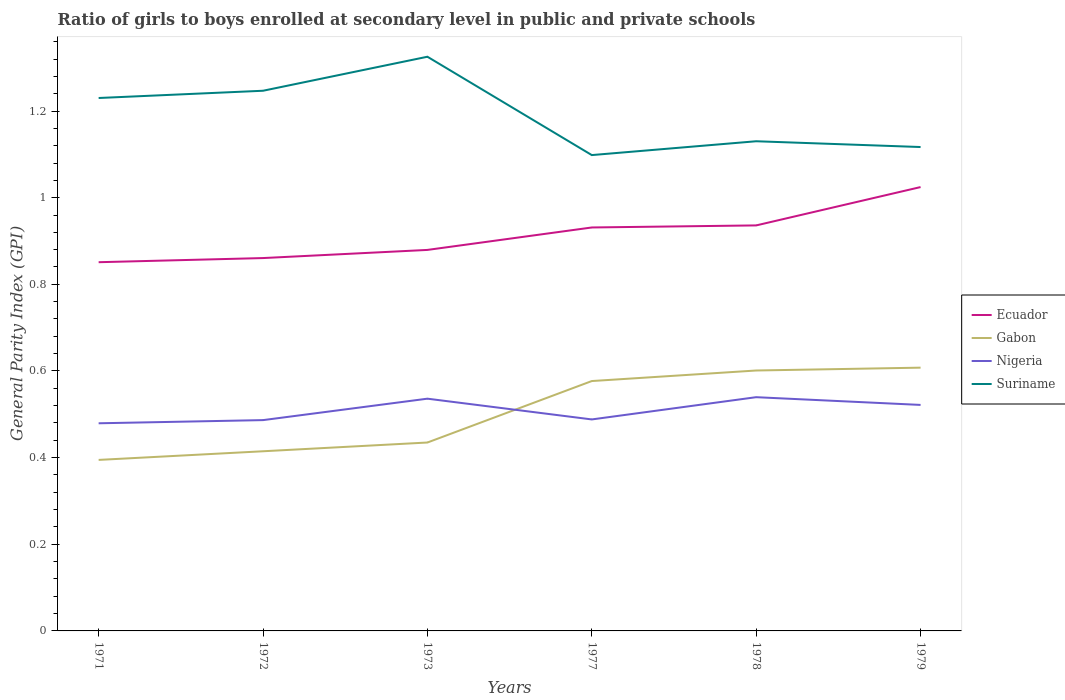How many different coloured lines are there?
Keep it short and to the point. 4. Across all years, what is the maximum general parity index in Nigeria?
Provide a succinct answer. 0.48. In which year was the general parity index in Suriname maximum?
Ensure brevity in your answer.  1977. What is the total general parity index in Nigeria in the graph?
Make the answer very short. 0.02. What is the difference between the highest and the second highest general parity index in Suriname?
Provide a short and direct response. 0.23. Is the general parity index in Ecuador strictly greater than the general parity index in Gabon over the years?
Your answer should be compact. No. How many years are there in the graph?
Give a very brief answer. 6. Does the graph contain any zero values?
Your answer should be very brief. No. Where does the legend appear in the graph?
Provide a succinct answer. Center right. How are the legend labels stacked?
Offer a very short reply. Vertical. What is the title of the graph?
Provide a short and direct response. Ratio of girls to boys enrolled at secondary level in public and private schools. What is the label or title of the X-axis?
Your answer should be compact. Years. What is the label or title of the Y-axis?
Ensure brevity in your answer.  General Parity Index (GPI). What is the General Parity Index (GPI) in Ecuador in 1971?
Keep it short and to the point. 0.85. What is the General Parity Index (GPI) of Gabon in 1971?
Offer a terse response. 0.39. What is the General Parity Index (GPI) in Nigeria in 1971?
Provide a succinct answer. 0.48. What is the General Parity Index (GPI) in Suriname in 1971?
Offer a terse response. 1.23. What is the General Parity Index (GPI) of Ecuador in 1972?
Offer a very short reply. 0.86. What is the General Parity Index (GPI) of Gabon in 1972?
Your answer should be compact. 0.41. What is the General Parity Index (GPI) of Nigeria in 1972?
Make the answer very short. 0.49. What is the General Parity Index (GPI) of Suriname in 1972?
Ensure brevity in your answer.  1.25. What is the General Parity Index (GPI) in Ecuador in 1973?
Your answer should be very brief. 0.88. What is the General Parity Index (GPI) of Gabon in 1973?
Your answer should be very brief. 0.43. What is the General Parity Index (GPI) in Nigeria in 1973?
Provide a succinct answer. 0.54. What is the General Parity Index (GPI) in Suriname in 1973?
Provide a succinct answer. 1.33. What is the General Parity Index (GPI) in Ecuador in 1977?
Offer a very short reply. 0.93. What is the General Parity Index (GPI) of Gabon in 1977?
Offer a terse response. 0.58. What is the General Parity Index (GPI) of Nigeria in 1977?
Keep it short and to the point. 0.49. What is the General Parity Index (GPI) of Suriname in 1977?
Your response must be concise. 1.1. What is the General Parity Index (GPI) in Ecuador in 1978?
Your response must be concise. 0.94. What is the General Parity Index (GPI) in Gabon in 1978?
Offer a very short reply. 0.6. What is the General Parity Index (GPI) of Nigeria in 1978?
Your answer should be compact. 0.54. What is the General Parity Index (GPI) of Suriname in 1978?
Keep it short and to the point. 1.13. What is the General Parity Index (GPI) of Ecuador in 1979?
Ensure brevity in your answer.  1.02. What is the General Parity Index (GPI) of Gabon in 1979?
Provide a short and direct response. 0.61. What is the General Parity Index (GPI) of Nigeria in 1979?
Ensure brevity in your answer.  0.52. What is the General Parity Index (GPI) of Suriname in 1979?
Ensure brevity in your answer.  1.12. Across all years, what is the maximum General Parity Index (GPI) of Ecuador?
Your answer should be compact. 1.02. Across all years, what is the maximum General Parity Index (GPI) of Gabon?
Your response must be concise. 0.61. Across all years, what is the maximum General Parity Index (GPI) of Nigeria?
Keep it short and to the point. 0.54. Across all years, what is the maximum General Parity Index (GPI) in Suriname?
Give a very brief answer. 1.33. Across all years, what is the minimum General Parity Index (GPI) of Ecuador?
Ensure brevity in your answer.  0.85. Across all years, what is the minimum General Parity Index (GPI) of Gabon?
Your response must be concise. 0.39. Across all years, what is the minimum General Parity Index (GPI) in Nigeria?
Give a very brief answer. 0.48. Across all years, what is the minimum General Parity Index (GPI) of Suriname?
Your response must be concise. 1.1. What is the total General Parity Index (GPI) in Ecuador in the graph?
Your answer should be very brief. 5.48. What is the total General Parity Index (GPI) in Gabon in the graph?
Keep it short and to the point. 3.03. What is the total General Parity Index (GPI) in Nigeria in the graph?
Keep it short and to the point. 3.05. What is the total General Parity Index (GPI) of Suriname in the graph?
Ensure brevity in your answer.  7.15. What is the difference between the General Parity Index (GPI) of Ecuador in 1971 and that in 1972?
Your answer should be compact. -0.01. What is the difference between the General Parity Index (GPI) of Gabon in 1971 and that in 1972?
Your answer should be compact. -0.02. What is the difference between the General Parity Index (GPI) of Nigeria in 1971 and that in 1972?
Keep it short and to the point. -0.01. What is the difference between the General Parity Index (GPI) of Suriname in 1971 and that in 1972?
Keep it short and to the point. -0.02. What is the difference between the General Parity Index (GPI) of Ecuador in 1971 and that in 1973?
Offer a terse response. -0.03. What is the difference between the General Parity Index (GPI) in Gabon in 1971 and that in 1973?
Keep it short and to the point. -0.04. What is the difference between the General Parity Index (GPI) in Nigeria in 1971 and that in 1973?
Provide a succinct answer. -0.06. What is the difference between the General Parity Index (GPI) of Suriname in 1971 and that in 1973?
Give a very brief answer. -0.1. What is the difference between the General Parity Index (GPI) in Ecuador in 1971 and that in 1977?
Your answer should be very brief. -0.08. What is the difference between the General Parity Index (GPI) of Gabon in 1971 and that in 1977?
Provide a succinct answer. -0.18. What is the difference between the General Parity Index (GPI) of Nigeria in 1971 and that in 1977?
Give a very brief answer. -0.01. What is the difference between the General Parity Index (GPI) in Suriname in 1971 and that in 1977?
Your answer should be very brief. 0.13. What is the difference between the General Parity Index (GPI) in Ecuador in 1971 and that in 1978?
Give a very brief answer. -0.08. What is the difference between the General Parity Index (GPI) in Gabon in 1971 and that in 1978?
Ensure brevity in your answer.  -0.21. What is the difference between the General Parity Index (GPI) in Nigeria in 1971 and that in 1978?
Give a very brief answer. -0.06. What is the difference between the General Parity Index (GPI) in Suriname in 1971 and that in 1978?
Provide a succinct answer. 0.1. What is the difference between the General Parity Index (GPI) in Ecuador in 1971 and that in 1979?
Make the answer very short. -0.17. What is the difference between the General Parity Index (GPI) of Gabon in 1971 and that in 1979?
Offer a terse response. -0.21. What is the difference between the General Parity Index (GPI) of Nigeria in 1971 and that in 1979?
Provide a succinct answer. -0.04. What is the difference between the General Parity Index (GPI) of Suriname in 1971 and that in 1979?
Offer a terse response. 0.11. What is the difference between the General Parity Index (GPI) in Ecuador in 1972 and that in 1973?
Your response must be concise. -0.02. What is the difference between the General Parity Index (GPI) of Gabon in 1972 and that in 1973?
Give a very brief answer. -0.02. What is the difference between the General Parity Index (GPI) of Nigeria in 1972 and that in 1973?
Make the answer very short. -0.05. What is the difference between the General Parity Index (GPI) of Suriname in 1972 and that in 1973?
Give a very brief answer. -0.08. What is the difference between the General Parity Index (GPI) in Ecuador in 1972 and that in 1977?
Make the answer very short. -0.07. What is the difference between the General Parity Index (GPI) in Gabon in 1972 and that in 1977?
Your answer should be compact. -0.16. What is the difference between the General Parity Index (GPI) in Nigeria in 1972 and that in 1977?
Give a very brief answer. -0. What is the difference between the General Parity Index (GPI) of Suriname in 1972 and that in 1977?
Provide a short and direct response. 0.15. What is the difference between the General Parity Index (GPI) in Ecuador in 1972 and that in 1978?
Your answer should be very brief. -0.08. What is the difference between the General Parity Index (GPI) of Gabon in 1972 and that in 1978?
Offer a very short reply. -0.19. What is the difference between the General Parity Index (GPI) in Nigeria in 1972 and that in 1978?
Offer a very short reply. -0.05. What is the difference between the General Parity Index (GPI) of Suriname in 1972 and that in 1978?
Offer a very short reply. 0.12. What is the difference between the General Parity Index (GPI) of Ecuador in 1972 and that in 1979?
Provide a short and direct response. -0.16. What is the difference between the General Parity Index (GPI) of Gabon in 1972 and that in 1979?
Offer a terse response. -0.19. What is the difference between the General Parity Index (GPI) in Nigeria in 1972 and that in 1979?
Keep it short and to the point. -0.04. What is the difference between the General Parity Index (GPI) of Suriname in 1972 and that in 1979?
Provide a succinct answer. 0.13. What is the difference between the General Parity Index (GPI) in Ecuador in 1973 and that in 1977?
Offer a very short reply. -0.05. What is the difference between the General Parity Index (GPI) in Gabon in 1973 and that in 1977?
Your answer should be very brief. -0.14. What is the difference between the General Parity Index (GPI) of Nigeria in 1973 and that in 1977?
Make the answer very short. 0.05. What is the difference between the General Parity Index (GPI) in Suriname in 1973 and that in 1977?
Provide a short and direct response. 0.23. What is the difference between the General Parity Index (GPI) in Ecuador in 1973 and that in 1978?
Make the answer very short. -0.06. What is the difference between the General Parity Index (GPI) of Gabon in 1973 and that in 1978?
Your answer should be compact. -0.17. What is the difference between the General Parity Index (GPI) of Nigeria in 1973 and that in 1978?
Offer a very short reply. -0. What is the difference between the General Parity Index (GPI) in Suriname in 1973 and that in 1978?
Give a very brief answer. 0.2. What is the difference between the General Parity Index (GPI) of Ecuador in 1973 and that in 1979?
Your answer should be compact. -0.14. What is the difference between the General Parity Index (GPI) in Gabon in 1973 and that in 1979?
Your response must be concise. -0.17. What is the difference between the General Parity Index (GPI) in Nigeria in 1973 and that in 1979?
Offer a terse response. 0.01. What is the difference between the General Parity Index (GPI) in Suriname in 1973 and that in 1979?
Provide a short and direct response. 0.21. What is the difference between the General Parity Index (GPI) of Ecuador in 1977 and that in 1978?
Offer a very short reply. -0. What is the difference between the General Parity Index (GPI) in Gabon in 1977 and that in 1978?
Offer a terse response. -0.02. What is the difference between the General Parity Index (GPI) in Nigeria in 1977 and that in 1978?
Offer a very short reply. -0.05. What is the difference between the General Parity Index (GPI) of Suriname in 1977 and that in 1978?
Your answer should be very brief. -0.03. What is the difference between the General Parity Index (GPI) of Ecuador in 1977 and that in 1979?
Offer a very short reply. -0.09. What is the difference between the General Parity Index (GPI) of Gabon in 1977 and that in 1979?
Offer a very short reply. -0.03. What is the difference between the General Parity Index (GPI) of Nigeria in 1977 and that in 1979?
Your answer should be very brief. -0.03. What is the difference between the General Parity Index (GPI) in Suriname in 1977 and that in 1979?
Provide a short and direct response. -0.02. What is the difference between the General Parity Index (GPI) of Ecuador in 1978 and that in 1979?
Your answer should be very brief. -0.09. What is the difference between the General Parity Index (GPI) of Gabon in 1978 and that in 1979?
Offer a very short reply. -0.01. What is the difference between the General Parity Index (GPI) of Nigeria in 1978 and that in 1979?
Your response must be concise. 0.02. What is the difference between the General Parity Index (GPI) of Suriname in 1978 and that in 1979?
Keep it short and to the point. 0.01. What is the difference between the General Parity Index (GPI) of Ecuador in 1971 and the General Parity Index (GPI) of Gabon in 1972?
Provide a succinct answer. 0.44. What is the difference between the General Parity Index (GPI) in Ecuador in 1971 and the General Parity Index (GPI) in Nigeria in 1972?
Offer a terse response. 0.36. What is the difference between the General Parity Index (GPI) of Ecuador in 1971 and the General Parity Index (GPI) of Suriname in 1972?
Offer a terse response. -0.4. What is the difference between the General Parity Index (GPI) in Gabon in 1971 and the General Parity Index (GPI) in Nigeria in 1972?
Give a very brief answer. -0.09. What is the difference between the General Parity Index (GPI) of Gabon in 1971 and the General Parity Index (GPI) of Suriname in 1972?
Offer a terse response. -0.85. What is the difference between the General Parity Index (GPI) in Nigeria in 1971 and the General Parity Index (GPI) in Suriname in 1972?
Make the answer very short. -0.77. What is the difference between the General Parity Index (GPI) in Ecuador in 1971 and the General Parity Index (GPI) in Gabon in 1973?
Offer a terse response. 0.42. What is the difference between the General Parity Index (GPI) in Ecuador in 1971 and the General Parity Index (GPI) in Nigeria in 1973?
Provide a short and direct response. 0.32. What is the difference between the General Parity Index (GPI) of Ecuador in 1971 and the General Parity Index (GPI) of Suriname in 1973?
Provide a short and direct response. -0.47. What is the difference between the General Parity Index (GPI) of Gabon in 1971 and the General Parity Index (GPI) of Nigeria in 1973?
Your response must be concise. -0.14. What is the difference between the General Parity Index (GPI) of Gabon in 1971 and the General Parity Index (GPI) of Suriname in 1973?
Offer a terse response. -0.93. What is the difference between the General Parity Index (GPI) in Nigeria in 1971 and the General Parity Index (GPI) in Suriname in 1973?
Your answer should be very brief. -0.85. What is the difference between the General Parity Index (GPI) of Ecuador in 1971 and the General Parity Index (GPI) of Gabon in 1977?
Ensure brevity in your answer.  0.27. What is the difference between the General Parity Index (GPI) of Ecuador in 1971 and the General Parity Index (GPI) of Nigeria in 1977?
Provide a short and direct response. 0.36. What is the difference between the General Parity Index (GPI) of Ecuador in 1971 and the General Parity Index (GPI) of Suriname in 1977?
Offer a very short reply. -0.25. What is the difference between the General Parity Index (GPI) of Gabon in 1971 and the General Parity Index (GPI) of Nigeria in 1977?
Your answer should be compact. -0.09. What is the difference between the General Parity Index (GPI) of Gabon in 1971 and the General Parity Index (GPI) of Suriname in 1977?
Your answer should be very brief. -0.7. What is the difference between the General Parity Index (GPI) in Nigeria in 1971 and the General Parity Index (GPI) in Suriname in 1977?
Provide a succinct answer. -0.62. What is the difference between the General Parity Index (GPI) in Ecuador in 1971 and the General Parity Index (GPI) in Nigeria in 1978?
Offer a terse response. 0.31. What is the difference between the General Parity Index (GPI) of Ecuador in 1971 and the General Parity Index (GPI) of Suriname in 1978?
Your response must be concise. -0.28. What is the difference between the General Parity Index (GPI) in Gabon in 1971 and the General Parity Index (GPI) in Nigeria in 1978?
Keep it short and to the point. -0.14. What is the difference between the General Parity Index (GPI) in Gabon in 1971 and the General Parity Index (GPI) in Suriname in 1978?
Offer a terse response. -0.74. What is the difference between the General Parity Index (GPI) in Nigeria in 1971 and the General Parity Index (GPI) in Suriname in 1978?
Give a very brief answer. -0.65. What is the difference between the General Parity Index (GPI) in Ecuador in 1971 and the General Parity Index (GPI) in Gabon in 1979?
Your answer should be very brief. 0.24. What is the difference between the General Parity Index (GPI) of Ecuador in 1971 and the General Parity Index (GPI) of Nigeria in 1979?
Make the answer very short. 0.33. What is the difference between the General Parity Index (GPI) of Ecuador in 1971 and the General Parity Index (GPI) of Suriname in 1979?
Your answer should be very brief. -0.27. What is the difference between the General Parity Index (GPI) of Gabon in 1971 and the General Parity Index (GPI) of Nigeria in 1979?
Offer a terse response. -0.13. What is the difference between the General Parity Index (GPI) in Gabon in 1971 and the General Parity Index (GPI) in Suriname in 1979?
Keep it short and to the point. -0.72. What is the difference between the General Parity Index (GPI) of Nigeria in 1971 and the General Parity Index (GPI) of Suriname in 1979?
Your answer should be compact. -0.64. What is the difference between the General Parity Index (GPI) of Ecuador in 1972 and the General Parity Index (GPI) of Gabon in 1973?
Ensure brevity in your answer.  0.43. What is the difference between the General Parity Index (GPI) of Ecuador in 1972 and the General Parity Index (GPI) of Nigeria in 1973?
Provide a short and direct response. 0.32. What is the difference between the General Parity Index (GPI) of Ecuador in 1972 and the General Parity Index (GPI) of Suriname in 1973?
Ensure brevity in your answer.  -0.46. What is the difference between the General Parity Index (GPI) in Gabon in 1972 and the General Parity Index (GPI) in Nigeria in 1973?
Your answer should be very brief. -0.12. What is the difference between the General Parity Index (GPI) in Gabon in 1972 and the General Parity Index (GPI) in Suriname in 1973?
Provide a short and direct response. -0.91. What is the difference between the General Parity Index (GPI) of Nigeria in 1972 and the General Parity Index (GPI) of Suriname in 1973?
Provide a short and direct response. -0.84. What is the difference between the General Parity Index (GPI) of Ecuador in 1972 and the General Parity Index (GPI) of Gabon in 1977?
Give a very brief answer. 0.28. What is the difference between the General Parity Index (GPI) of Ecuador in 1972 and the General Parity Index (GPI) of Nigeria in 1977?
Ensure brevity in your answer.  0.37. What is the difference between the General Parity Index (GPI) of Ecuador in 1972 and the General Parity Index (GPI) of Suriname in 1977?
Provide a short and direct response. -0.24. What is the difference between the General Parity Index (GPI) in Gabon in 1972 and the General Parity Index (GPI) in Nigeria in 1977?
Make the answer very short. -0.07. What is the difference between the General Parity Index (GPI) of Gabon in 1972 and the General Parity Index (GPI) of Suriname in 1977?
Offer a very short reply. -0.68. What is the difference between the General Parity Index (GPI) in Nigeria in 1972 and the General Parity Index (GPI) in Suriname in 1977?
Give a very brief answer. -0.61. What is the difference between the General Parity Index (GPI) of Ecuador in 1972 and the General Parity Index (GPI) of Gabon in 1978?
Offer a terse response. 0.26. What is the difference between the General Parity Index (GPI) of Ecuador in 1972 and the General Parity Index (GPI) of Nigeria in 1978?
Ensure brevity in your answer.  0.32. What is the difference between the General Parity Index (GPI) of Ecuador in 1972 and the General Parity Index (GPI) of Suriname in 1978?
Ensure brevity in your answer.  -0.27. What is the difference between the General Parity Index (GPI) of Gabon in 1972 and the General Parity Index (GPI) of Nigeria in 1978?
Provide a succinct answer. -0.12. What is the difference between the General Parity Index (GPI) in Gabon in 1972 and the General Parity Index (GPI) in Suriname in 1978?
Your answer should be very brief. -0.72. What is the difference between the General Parity Index (GPI) in Nigeria in 1972 and the General Parity Index (GPI) in Suriname in 1978?
Ensure brevity in your answer.  -0.64. What is the difference between the General Parity Index (GPI) in Ecuador in 1972 and the General Parity Index (GPI) in Gabon in 1979?
Your answer should be compact. 0.25. What is the difference between the General Parity Index (GPI) in Ecuador in 1972 and the General Parity Index (GPI) in Nigeria in 1979?
Offer a very short reply. 0.34. What is the difference between the General Parity Index (GPI) in Ecuador in 1972 and the General Parity Index (GPI) in Suriname in 1979?
Give a very brief answer. -0.26. What is the difference between the General Parity Index (GPI) in Gabon in 1972 and the General Parity Index (GPI) in Nigeria in 1979?
Your response must be concise. -0.11. What is the difference between the General Parity Index (GPI) in Gabon in 1972 and the General Parity Index (GPI) in Suriname in 1979?
Provide a succinct answer. -0.7. What is the difference between the General Parity Index (GPI) of Nigeria in 1972 and the General Parity Index (GPI) of Suriname in 1979?
Ensure brevity in your answer.  -0.63. What is the difference between the General Parity Index (GPI) of Ecuador in 1973 and the General Parity Index (GPI) of Gabon in 1977?
Ensure brevity in your answer.  0.3. What is the difference between the General Parity Index (GPI) in Ecuador in 1973 and the General Parity Index (GPI) in Nigeria in 1977?
Ensure brevity in your answer.  0.39. What is the difference between the General Parity Index (GPI) of Ecuador in 1973 and the General Parity Index (GPI) of Suriname in 1977?
Provide a short and direct response. -0.22. What is the difference between the General Parity Index (GPI) in Gabon in 1973 and the General Parity Index (GPI) in Nigeria in 1977?
Offer a terse response. -0.05. What is the difference between the General Parity Index (GPI) of Gabon in 1973 and the General Parity Index (GPI) of Suriname in 1977?
Ensure brevity in your answer.  -0.66. What is the difference between the General Parity Index (GPI) in Nigeria in 1973 and the General Parity Index (GPI) in Suriname in 1977?
Keep it short and to the point. -0.56. What is the difference between the General Parity Index (GPI) in Ecuador in 1973 and the General Parity Index (GPI) in Gabon in 1978?
Provide a succinct answer. 0.28. What is the difference between the General Parity Index (GPI) of Ecuador in 1973 and the General Parity Index (GPI) of Nigeria in 1978?
Keep it short and to the point. 0.34. What is the difference between the General Parity Index (GPI) of Ecuador in 1973 and the General Parity Index (GPI) of Suriname in 1978?
Ensure brevity in your answer.  -0.25. What is the difference between the General Parity Index (GPI) of Gabon in 1973 and the General Parity Index (GPI) of Nigeria in 1978?
Your answer should be compact. -0.1. What is the difference between the General Parity Index (GPI) in Gabon in 1973 and the General Parity Index (GPI) in Suriname in 1978?
Provide a succinct answer. -0.7. What is the difference between the General Parity Index (GPI) in Nigeria in 1973 and the General Parity Index (GPI) in Suriname in 1978?
Your response must be concise. -0.59. What is the difference between the General Parity Index (GPI) of Ecuador in 1973 and the General Parity Index (GPI) of Gabon in 1979?
Provide a short and direct response. 0.27. What is the difference between the General Parity Index (GPI) in Ecuador in 1973 and the General Parity Index (GPI) in Nigeria in 1979?
Your response must be concise. 0.36. What is the difference between the General Parity Index (GPI) in Ecuador in 1973 and the General Parity Index (GPI) in Suriname in 1979?
Your response must be concise. -0.24. What is the difference between the General Parity Index (GPI) in Gabon in 1973 and the General Parity Index (GPI) in Nigeria in 1979?
Provide a short and direct response. -0.09. What is the difference between the General Parity Index (GPI) of Gabon in 1973 and the General Parity Index (GPI) of Suriname in 1979?
Your answer should be very brief. -0.68. What is the difference between the General Parity Index (GPI) of Nigeria in 1973 and the General Parity Index (GPI) of Suriname in 1979?
Make the answer very short. -0.58. What is the difference between the General Parity Index (GPI) in Ecuador in 1977 and the General Parity Index (GPI) in Gabon in 1978?
Your answer should be compact. 0.33. What is the difference between the General Parity Index (GPI) in Ecuador in 1977 and the General Parity Index (GPI) in Nigeria in 1978?
Ensure brevity in your answer.  0.39. What is the difference between the General Parity Index (GPI) in Ecuador in 1977 and the General Parity Index (GPI) in Suriname in 1978?
Make the answer very short. -0.2. What is the difference between the General Parity Index (GPI) of Gabon in 1977 and the General Parity Index (GPI) of Nigeria in 1978?
Your answer should be compact. 0.04. What is the difference between the General Parity Index (GPI) of Gabon in 1977 and the General Parity Index (GPI) of Suriname in 1978?
Offer a very short reply. -0.55. What is the difference between the General Parity Index (GPI) of Nigeria in 1977 and the General Parity Index (GPI) of Suriname in 1978?
Your response must be concise. -0.64. What is the difference between the General Parity Index (GPI) in Ecuador in 1977 and the General Parity Index (GPI) in Gabon in 1979?
Give a very brief answer. 0.32. What is the difference between the General Parity Index (GPI) of Ecuador in 1977 and the General Parity Index (GPI) of Nigeria in 1979?
Offer a very short reply. 0.41. What is the difference between the General Parity Index (GPI) in Ecuador in 1977 and the General Parity Index (GPI) in Suriname in 1979?
Ensure brevity in your answer.  -0.19. What is the difference between the General Parity Index (GPI) in Gabon in 1977 and the General Parity Index (GPI) in Nigeria in 1979?
Offer a very short reply. 0.06. What is the difference between the General Parity Index (GPI) in Gabon in 1977 and the General Parity Index (GPI) in Suriname in 1979?
Your response must be concise. -0.54. What is the difference between the General Parity Index (GPI) of Nigeria in 1977 and the General Parity Index (GPI) of Suriname in 1979?
Offer a very short reply. -0.63. What is the difference between the General Parity Index (GPI) of Ecuador in 1978 and the General Parity Index (GPI) of Gabon in 1979?
Provide a succinct answer. 0.33. What is the difference between the General Parity Index (GPI) in Ecuador in 1978 and the General Parity Index (GPI) in Nigeria in 1979?
Your response must be concise. 0.41. What is the difference between the General Parity Index (GPI) of Ecuador in 1978 and the General Parity Index (GPI) of Suriname in 1979?
Your response must be concise. -0.18. What is the difference between the General Parity Index (GPI) of Gabon in 1978 and the General Parity Index (GPI) of Nigeria in 1979?
Provide a succinct answer. 0.08. What is the difference between the General Parity Index (GPI) of Gabon in 1978 and the General Parity Index (GPI) of Suriname in 1979?
Provide a succinct answer. -0.52. What is the difference between the General Parity Index (GPI) in Nigeria in 1978 and the General Parity Index (GPI) in Suriname in 1979?
Ensure brevity in your answer.  -0.58. What is the average General Parity Index (GPI) of Ecuador per year?
Your answer should be compact. 0.91. What is the average General Parity Index (GPI) of Gabon per year?
Your answer should be very brief. 0.51. What is the average General Parity Index (GPI) of Nigeria per year?
Offer a very short reply. 0.51. What is the average General Parity Index (GPI) of Suriname per year?
Your response must be concise. 1.19. In the year 1971, what is the difference between the General Parity Index (GPI) of Ecuador and General Parity Index (GPI) of Gabon?
Offer a very short reply. 0.46. In the year 1971, what is the difference between the General Parity Index (GPI) in Ecuador and General Parity Index (GPI) in Nigeria?
Your answer should be very brief. 0.37. In the year 1971, what is the difference between the General Parity Index (GPI) of Ecuador and General Parity Index (GPI) of Suriname?
Offer a very short reply. -0.38. In the year 1971, what is the difference between the General Parity Index (GPI) of Gabon and General Parity Index (GPI) of Nigeria?
Provide a short and direct response. -0.08. In the year 1971, what is the difference between the General Parity Index (GPI) in Gabon and General Parity Index (GPI) in Suriname?
Make the answer very short. -0.84. In the year 1971, what is the difference between the General Parity Index (GPI) of Nigeria and General Parity Index (GPI) of Suriname?
Ensure brevity in your answer.  -0.75. In the year 1972, what is the difference between the General Parity Index (GPI) in Ecuador and General Parity Index (GPI) in Gabon?
Offer a terse response. 0.45. In the year 1972, what is the difference between the General Parity Index (GPI) in Ecuador and General Parity Index (GPI) in Nigeria?
Your response must be concise. 0.37. In the year 1972, what is the difference between the General Parity Index (GPI) in Ecuador and General Parity Index (GPI) in Suriname?
Ensure brevity in your answer.  -0.39. In the year 1972, what is the difference between the General Parity Index (GPI) in Gabon and General Parity Index (GPI) in Nigeria?
Keep it short and to the point. -0.07. In the year 1972, what is the difference between the General Parity Index (GPI) in Gabon and General Parity Index (GPI) in Suriname?
Offer a terse response. -0.83. In the year 1972, what is the difference between the General Parity Index (GPI) of Nigeria and General Parity Index (GPI) of Suriname?
Your answer should be compact. -0.76. In the year 1973, what is the difference between the General Parity Index (GPI) of Ecuador and General Parity Index (GPI) of Gabon?
Your answer should be compact. 0.44. In the year 1973, what is the difference between the General Parity Index (GPI) in Ecuador and General Parity Index (GPI) in Nigeria?
Your response must be concise. 0.34. In the year 1973, what is the difference between the General Parity Index (GPI) of Ecuador and General Parity Index (GPI) of Suriname?
Keep it short and to the point. -0.45. In the year 1973, what is the difference between the General Parity Index (GPI) in Gabon and General Parity Index (GPI) in Nigeria?
Offer a very short reply. -0.1. In the year 1973, what is the difference between the General Parity Index (GPI) of Gabon and General Parity Index (GPI) of Suriname?
Your response must be concise. -0.89. In the year 1973, what is the difference between the General Parity Index (GPI) of Nigeria and General Parity Index (GPI) of Suriname?
Ensure brevity in your answer.  -0.79. In the year 1977, what is the difference between the General Parity Index (GPI) of Ecuador and General Parity Index (GPI) of Gabon?
Ensure brevity in your answer.  0.35. In the year 1977, what is the difference between the General Parity Index (GPI) of Ecuador and General Parity Index (GPI) of Nigeria?
Ensure brevity in your answer.  0.44. In the year 1977, what is the difference between the General Parity Index (GPI) in Ecuador and General Parity Index (GPI) in Suriname?
Provide a short and direct response. -0.17. In the year 1977, what is the difference between the General Parity Index (GPI) of Gabon and General Parity Index (GPI) of Nigeria?
Keep it short and to the point. 0.09. In the year 1977, what is the difference between the General Parity Index (GPI) of Gabon and General Parity Index (GPI) of Suriname?
Your answer should be compact. -0.52. In the year 1977, what is the difference between the General Parity Index (GPI) in Nigeria and General Parity Index (GPI) in Suriname?
Provide a short and direct response. -0.61. In the year 1978, what is the difference between the General Parity Index (GPI) of Ecuador and General Parity Index (GPI) of Gabon?
Provide a short and direct response. 0.33. In the year 1978, what is the difference between the General Parity Index (GPI) of Ecuador and General Parity Index (GPI) of Nigeria?
Give a very brief answer. 0.4. In the year 1978, what is the difference between the General Parity Index (GPI) in Ecuador and General Parity Index (GPI) in Suriname?
Give a very brief answer. -0.19. In the year 1978, what is the difference between the General Parity Index (GPI) of Gabon and General Parity Index (GPI) of Nigeria?
Your response must be concise. 0.06. In the year 1978, what is the difference between the General Parity Index (GPI) in Gabon and General Parity Index (GPI) in Suriname?
Provide a succinct answer. -0.53. In the year 1978, what is the difference between the General Parity Index (GPI) of Nigeria and General Parity Index (GPI) of Suriname?
Offer a terse response. -0.59. In the year 1979, what is the difference between the General Parity Index (GPI) in Ecuador and General Parity Index (GPI) in Gabon?
Offer a very short reply. 0.42. In the year 1979, what is the difference between the General Parity Index (GPI) in Ecuador and General Parity Index (GPI) in Nigeria?
Ensure brevity in your answer.  0.5. In the year 1979, what is the difference between the General Parity Index (GPI) of Ecuador and General Parity Index (GPI) of Suriname?
Offer a terse response. -0.09. In the year 1979, what is the difference between the General Parity Index (GPI) in Gabon and General Parity Index (GPI) in Nigeria?
Provide a short and direct response. 0.09. In the year 1979, what is the difference between the General Parity Index (GPI) in Gabon and General Parity Index (GPI) in Suriname?
Give a very brief answer. -0.51. In the year 1979, what is the difference between the General Parity Index (GPI) in Nigeria and General Parity Index (GPI) in Suriname?
Your answer should be compact. -0.6. What is the ratio of the General Parity Index (GPI) of Ecuador in 1971 to that in 1972?
Your answer should be very brief. 0.99. What is the ratio of the General Parity Index (GPI) in Gabon in 1971 to that in 1972?
Give a very brief answer. 0.95. What is the ratio of the General Parity Index (GPI) of Nigeria in 1971 to that in 1972?
Your answer should be compact. 0.98. What is the ratio of the General Parity Index (GPI) in Suriname in 1971 to that in 1972?
Keep it short and to the point. 0.99. What is the ratio of the General Parity Index (GPI) of Ecuador in 1971 to that in 1973?
Your answer should be compact. 0.97. What is the ratio of the General Parity Index (GPI) of Gabon in 1971 to that in 1973?
Your response must be concise. 0.91. What is the ratio of the General Parity Index (GPI) in Nigeria in 1971 to that in 1973?
Make the answer very short. 0.89. What is the ratio of the General Parity Index (GPI) in Suriname in 1971 to that in 1973?
Provide a short and direct response. 0.93. What is the ratio of the General Parity Index (GPI) of Ecuador in 1971 to that in 1977?
Your answer should be very brief. 0.91. What is the ratio of the General Parity Index (GPI) in Gabon in 1971 to that in 1977?
Keep it short and to the point. 0.68. What is the ratio of the General Parity Index (GPI) in Nigeria in 1971 to that in 1977?
Give a very brief answer. 0.98. What is the ratio of the General Parity Index (GPI) of Suriname in 1971 to that in 1977?
Provide a succinct answer. 1.12. What is the ratio of the General Parity Index (GPI) of Ecuador in 1971 to that in 1978?
Your answer should be very brief. 0.91. What is the ratio of the General Parity Index (GPI) of Gabon in 1971 to that in 1978?
Provide a succinct answer. 0.66. What is the ratio of the General Parity Index (GPI) in Nigeria in 1971 to that in 1978?
Your response must be concise. 0.89. What is the ratio of the General Parity Index (GPI) of Suriname in 1971 to that in 1978?
Offer a very short reply. 1.09. What is the ratio of the General Parity Index (GPI) in Ecuador in 1971 to that in 1979?
Offer a very short reply. 0.83. What is the ratio of the General Parity Index (GPI) in Gabon in 1971 to that in 1979?
Offer a terse response. 0.65. What is the ratio of the General Parity Index (GPI) in Nigeria in 1971 to that in 1979?
Provide a succinct answer. 0.92. What is the ratio of the General Parity Index (GPI) of Suriname in 1971 to that in 1979?
Your response must be concise. 1.1. What is the ratio of the General Parity Index (GPI) of Ecuador in 1972 to that in 1973?
Your answer should be compact. 0.98. What is the ratio of the General Parity Index (GPI) of Gabon in 1972 to that in 1973?
Your answer should be very brief. 0.95. What is the ratio of the General Parity Index (GPI) in Nigeria in 1972 to that in 1973?
Make the answer very short. 0.91. What is the ratio of the General Parity Index (GPI) of Suriname in 1972 to that in 1973?
Offer a very short reply. 0.94. What is the ratio of the General Parity Index (GPI) in Ecuador in 1972 to that in 1977?
Your answer should be compact. 0.92. What is the ratio of the General Parity Index (GPI) in Gabon in 1972 to that in 1977?
Make the answer very short. 0.72. What is the ratio of the General Parity Index (GPI) of Nigeria in 1972 to that in 1977?
Provide a succinct answer. 1. What is the ratio of the General Parity Index (GPI) of Suriname in 1972 to that in 1977?
Offer a terse response. 1.14. What is the ratio of the General Parity Index (GPI) in Ecuador in 1972 to that in 1978?
Your answer should be very brief. 0.92. What is the ratio of the General Parity Index (GPI) of Gabon in 1972 to that in 1978?
Keep it short and to the point. 0.69. What is the ratio of the General Parity Index (GPI) in Nigeria in 1972 to that in 1978?
Provide a short and direct response. 0.9. What is the ratio of the General Parity Index (GPI) in Suriname in 1972 to that in 1978?
Your answer should be very brief. 1.1. What is the ratio of the General Parity Index (GPI) in Ecuador in 1972 to that in 1979?
Offer a terse response. 0.84. What is the ratio of the General Parity Index (GPI) of Gabon in 1972 to that in 1979?
Your answer should be compact. 0.68. What is the ratio of the General Parity Index (GPI) of Nigeria in 1972 to that in 1979?
Your answer should be compact. 0.93. What is the ratio of the General Parity Index (GPI) of Suriname in 1972 to that in 1979?
Make the answer very short. 1.12. What is the ratio of the General Parity Index (GPI) of Ecuador in 1973 to that in 1977?
Your answer should be very brief. 0.94. What is the ratio of the General Parity Index (GPI) in Gabon in 1973 to that in 1977?
Provide a succinct answer. 0.75. What is the ratio of the General Parity Index (GPI) in Nigeria in 1973 to that in 1977?
Provide a short and direct response. 1.1. What is the ratio of the General Parity Index (GPI) in Suriname in 1973 to that in 1977?
Give a very brief answer. 1.21. What is the ratio of the General Parity Index (GPI) in Ecuador in 1973 to that in 1978?
Keep it short and to the point. 0.94. What is the ratio of the General Parity Index (GPI) in Gabon in 1973 to that in 1978?
Offer a terse response. 0.72. What is the ratio of the General Parity Index (GPI) in Suriname in 1973 to that in 1978?
Ensure brevity in your answer.  1.17. What is the ratio of the General Parity Index (GPI) of Ecuador in 1973 to that in 1979?
Ensure brevity in your answer.  0.86. What is the ratio of the General Parity Index (GPI) of Gabon in 1973 to that in 1979?
Offer a terse response. 0.72. What is the ratio of the General Parity Index (GPI) of Nigeria in 1973 to that in 1979?
Offer a terse response. 1.03. What is the ratio of the General Parity Index (GPI) in Suriname in 1973 to that in 1979?
Keep it short and to the point. 1.19. What is the ratio of the General Parity Index (GPI) of Gabon in 1977 to that in 1978?
Make the answer very short. 0.96. What is the ratio of the General Parity Index (GPI) in Nigeria in 1977 to that in 1978?
Offer a terse response. 0.9. What is the ratio of the General Parity Index (GPI) in Suriname in 1977 to that in 1978?
Your answer should be very brief. 0.97. What is the ratio of the General Parity Index (GPI) in Ecuador in 1977 to that in 1979?
Offer a very short reply. 0.91. What is the ratio of the General Parity Index (GPI) in Gabon in 1977 to that in 1979?
Keep it short and to the point. 0.95. What is the ratio of the General Parity Index (GPI) of Nigeria in 1977 to that in 1979?
Ensure brevity in your answer.  0.94. What is the ratio of the General Parity Index (GPI) in Suriname in 1977 to that in 1979?
Offer a very short reply. 0.98. What is the ratio of the General Parity Index (GPI) in Ecuador in 1978 to that in 1979?
Provide a succinct answer. 0.91. What is the ratio of the General Parity Index (GPI) of Gabon in 1978 to that in 1979?
Make the answer very short. 0.99. What is the ratio of the General Parity Index (GPI) in Nigeria in 1978 to that in 1979?
Ensure brevity in your answer.  1.03. What is the ratio of the General Parity Index (GPI) of Suriname in 1978 to that in 1979?
Your response must be concise. 1.01. What is the difference between the highest and the second highest General Parity Index (GPI) of Ecuador?
Offer a terse response. 0.09. What is the difference between the highest and the second highest General Parity Index (GPI) in Gabon?
Provide a succinct answer. 0.01. What is the difference between the highest and the second highest General Parity Index (GPI) in Nigeria?
Keep it short and to the point. 0. What is the difference between the highest and the second highest General Parity Index (GPI) in Suriname?
Ensure brevity in your answer.  0.08. What is the difference between the highest and the lowest General Parity Index (GPI) of Ecuador?
Ensure brevity in your answer.  0.17. What is the difference between the highest and the lowest General Parity Index (GPI) of Gabon?
Your response must be concise. 0.21. What is the difference between the highest and the lowest General Parity Index (GPI) of Nigeria?
Your response must be concise. 0.06. What is the difference between the highest and the lowest General Parity Index (GPI) of Suriname?
Give a very brief answer. 0.23. 